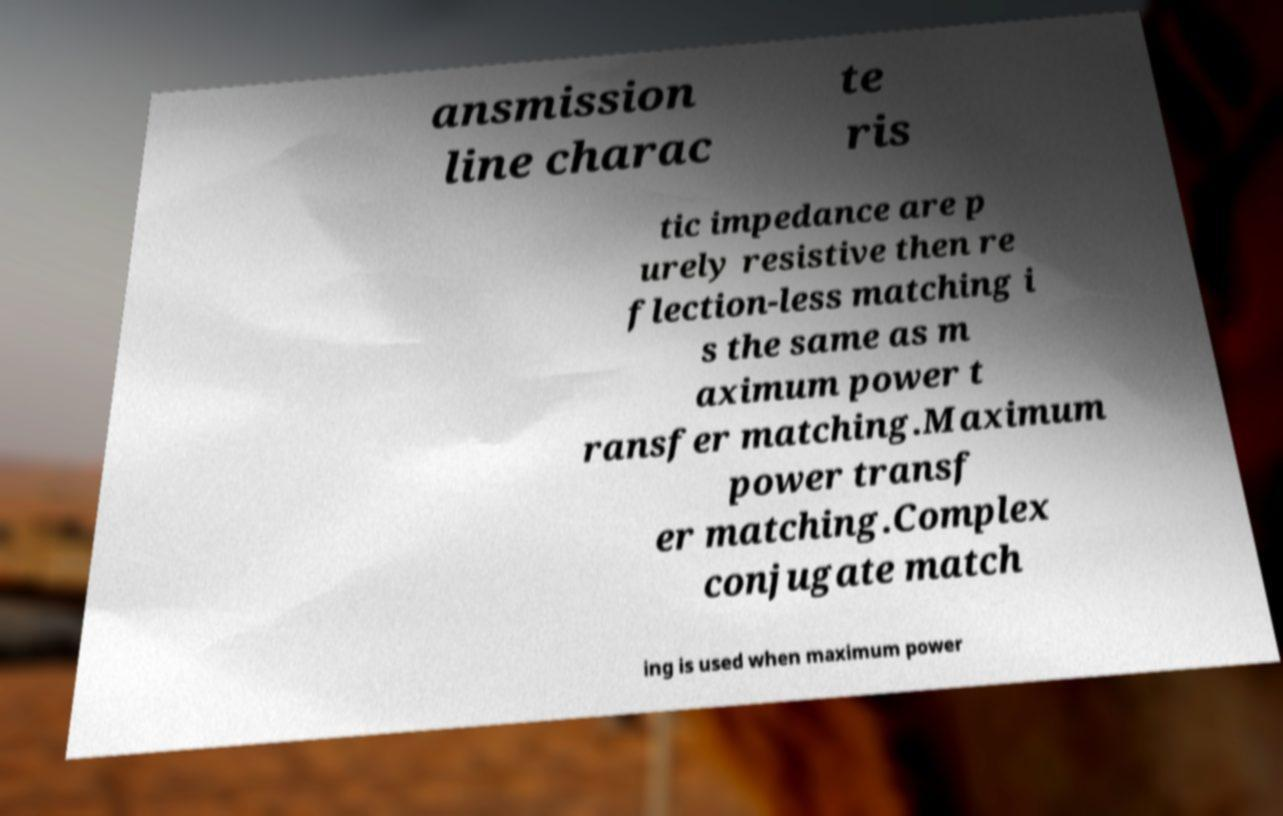Could you assist in decoding the text presented in this image and type it out clearly? ansmission line charac te ris tic impedance are p urely resistive then re flection-less matching i s the same as m aximum power t ransfer matching.Maximum power transf er matching.Complex conjugate match ing is used when maximum power 